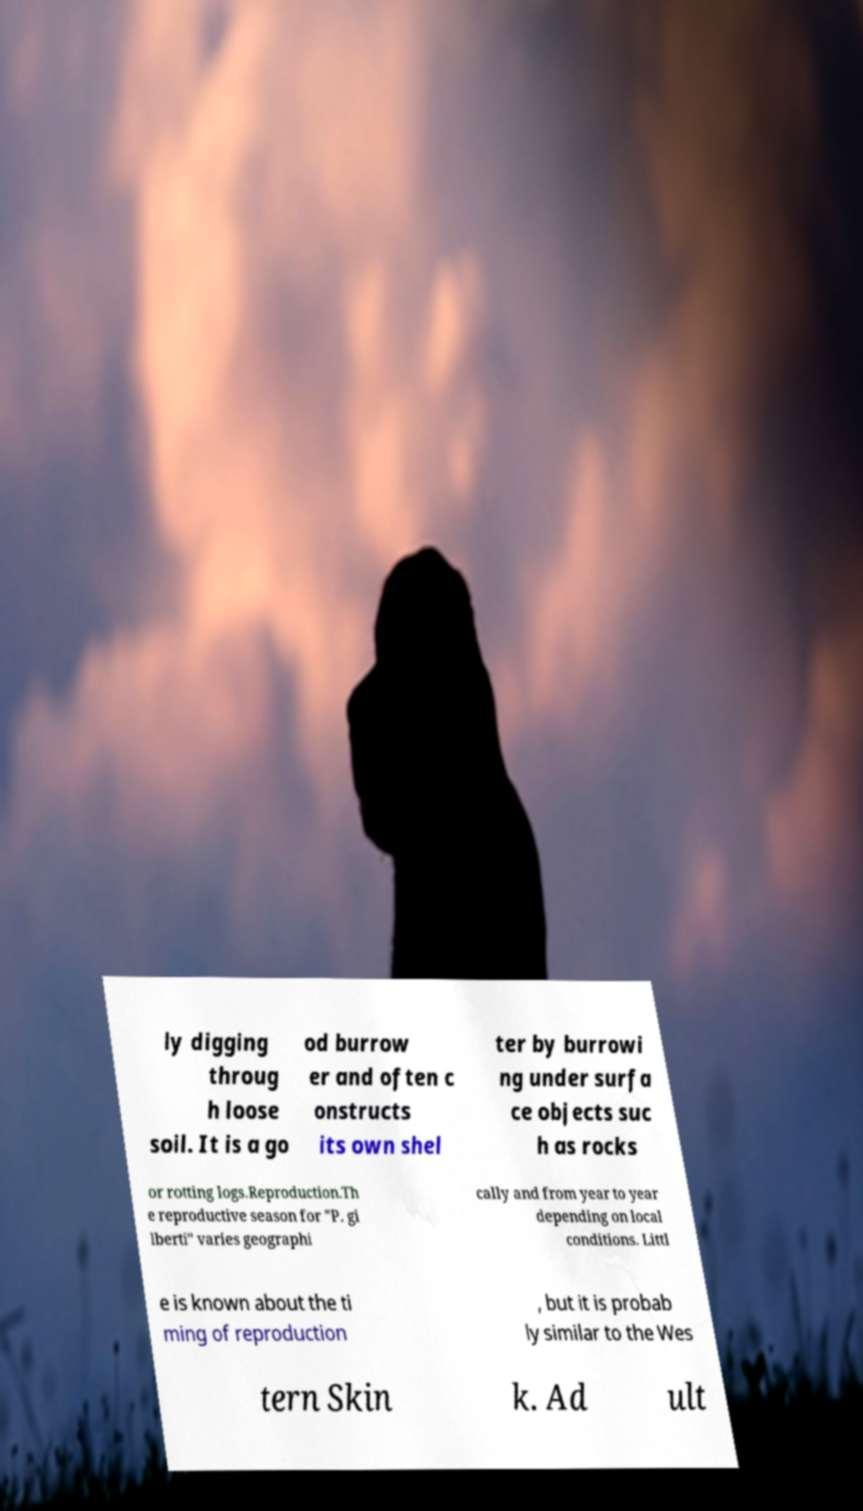Could you extract and type out the text from this image? ly digging throug h loose soil. It is a go od burrow er and often c onstructs its own shel ter by burrowi ng under surfa ce objects suc h as rocks or rotting logs.Reproduction.Th e reproductive season for "P. gi lberti" varies geographi cally and from year to year depending on local conditions. Littl e is known about the ti ming of reproduction , but it is probab ly similar to the Wes tern Skin k. Ad ult 